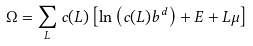<formula> <loc_0><loc_0><loc_500><loc_500>\Omega = \sum _ { L } c ( L ) \left [ \ln \left ( c ( L ) b ^ { d } \right ) + E + L \mu \right ]</formula> 